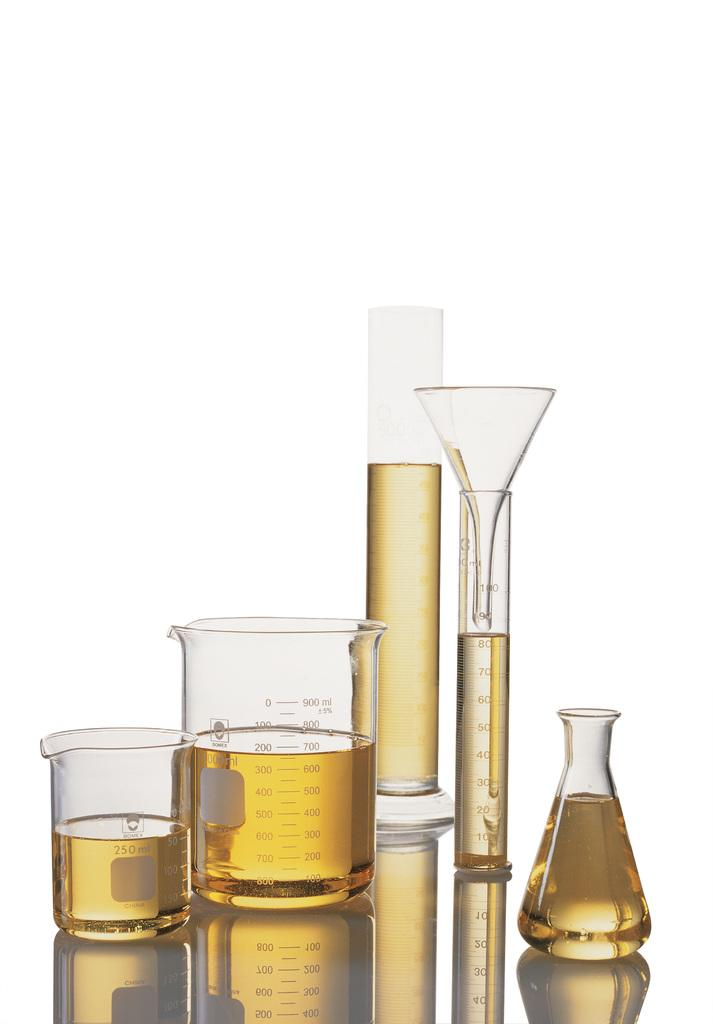What is the main object in the image containing liquid? There is a conical flask containing liquid in the image. What other objects in the image are related to measuring or transferring liquids? There are measuring jars and measuring cylinders in the image. What object in the image is used for guiding liquids into containers? There is a funnel in the image. What type of berry is being used to stir the liquid in the conical flask? There is no berry present in the image; it only contains a conical flask, measuring jars, measuring cylinders, and a funnel. 